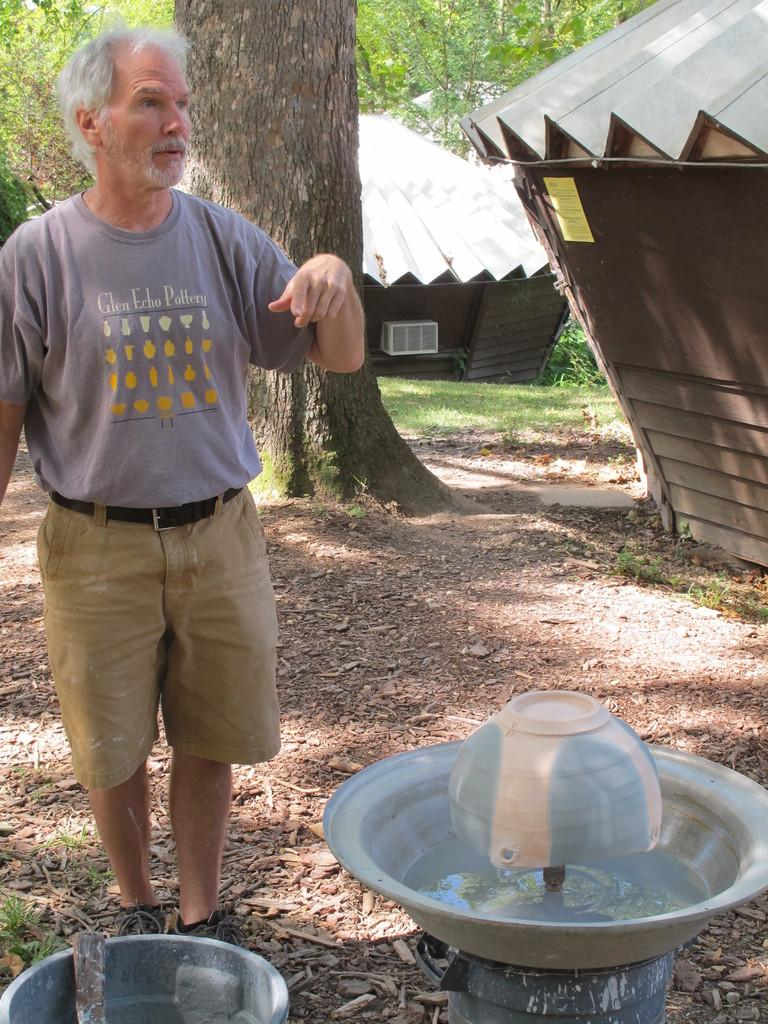<image>
Relay a brief, clear account of the picture shown. A man is wearing a tshirt from Glen Echo Pottery 